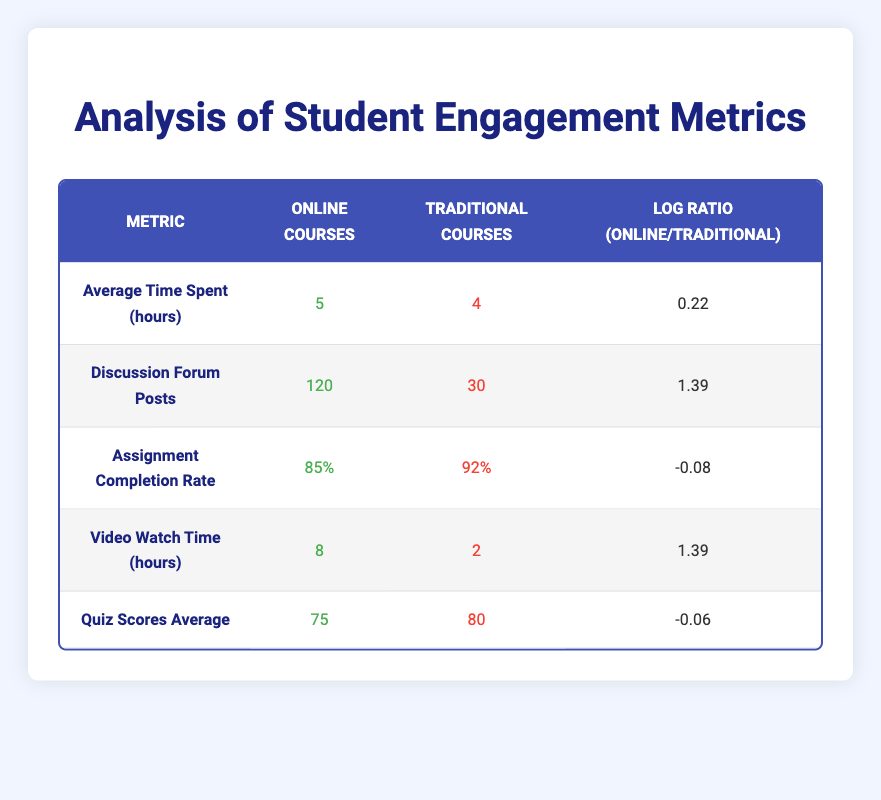What is the average time spent in online courses? The table shows that the average time spent in online courses is listed under the "Online Courses" column for the "Average Time Spent (hours)" metric, which is 5 hours.
Answer: 5 hours How many discussion forum posts did students make in traditional courses? The table indicates that for the "Discussion Forum Posts" metric, the value for traditional courses is found in the "Traditional Courses" column, which is 30 posts.
Answer: 30 posts Is the assignment completion rate higher for traditional courses compared to online courses? Looking at the "Assignment Completion Rate" metrics, traditional courses have a completion rate of 92% while online courses have 85%, meaning traditional courses have a higher rate.
Answer: Yes What is the log ratio for video watch time between online and traditional courses? The log ratio for video watch time is given in the table under "Video Watch Time (hours)" as 1.39 when comparing online courses (8 hours) to traditional courses (2 hours).
Answer: 1.39 What is the difference in average quiz scores between online and traditional courses? The average quiz score for online courses is 75 and for traditional courses, it is 80. The difference is calculated by subtracting the online score from the traditional score: 80 - 75 = 5.
Answer: 5 Do students in online courses spend more time engaging with videos compared to those in traditional courses? The table lists video watch time as 8 hours for online courses and 2 hours for traditional courses. Since 8 hours is greater than 2 hours, students in online courses spend more time engaging with videos.
Answer: Yes What is the average discussion forum posts made per hour for both course types? The average discussion forum posts per hour for online courses is calculated by dividing 120 posts by 5 hours, resulting in 24 posts/hour. For traditional courses, dividing 30 posts by 4 hours gives 7.5 posts/hour. The values are 24 and 7.5 respectively.
Answer: 24 posts/hour for online and 7.5 posts/hour for traditional Which course type has a better assignment completion rate relative to the other? While both rates are examined, traditional courses have a completion rate of 92%, while online courses have a rate of 85%. Since 92% is more than 85%, the comparison shows that traditional courses have a better rate.
Answer: Traditional courses What is the average video watch time across both course types combined? To find the average video watch time, add the video watch times from both courses: 8 (online) + 2 (traditional) = 10 hours. Then divide by 2 (the number of course types): 10/2 = 5 hours average.
Answer: 5 hours 